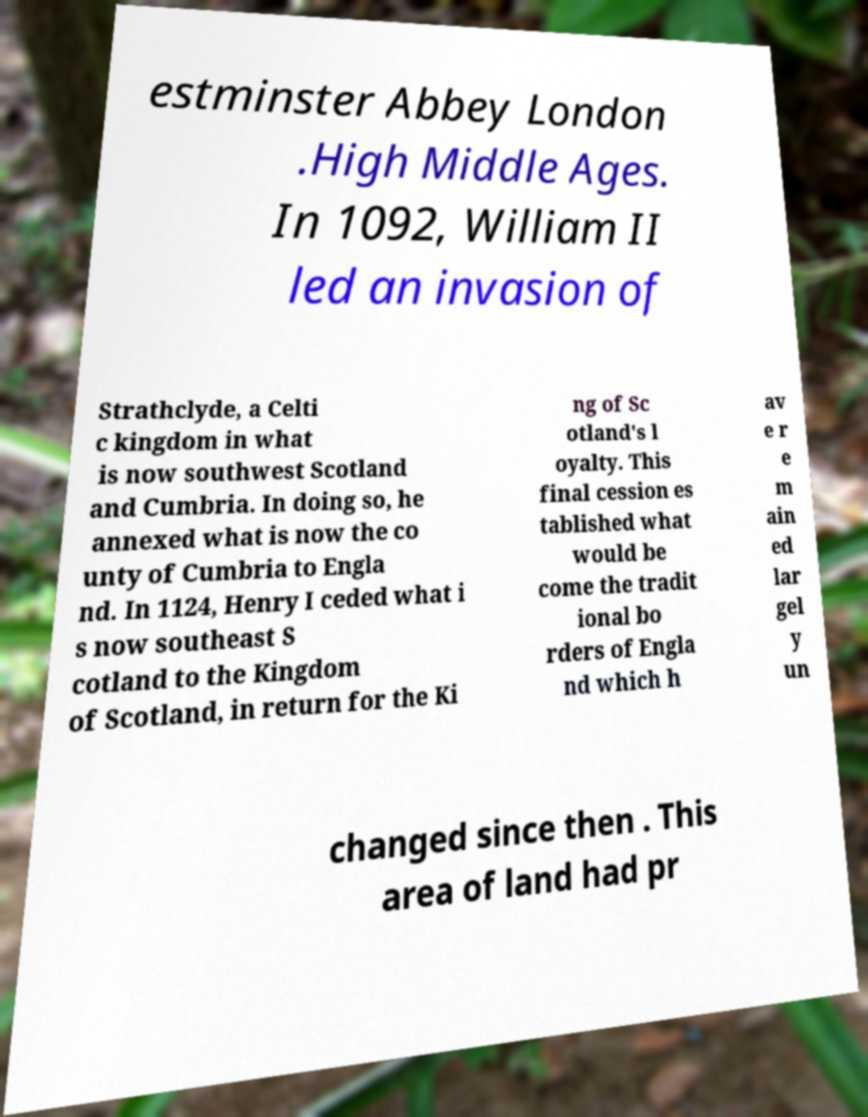Could you assist in decoding the text presented in this image and type it out clearly? estminster Abbey London .High Middle Ages. In 1092, William II led an invasion of Strathclyde, a Celti c kingdom in what is now southwest Scotland and Cumbria. In doing so, he annexed what is now the co unty of Cumbria to Engla nd. In 1124, Henry I ceded what i s now southeast S cotland to the Kingdom of Scotland, in return for the Ki ng of Sc otland's l oyalty. This final cession es tablished what would be come the tradit ional bo rders of Engla nd which h av e r e m ain ed lar gel y un changed since then . This area of land had pr 